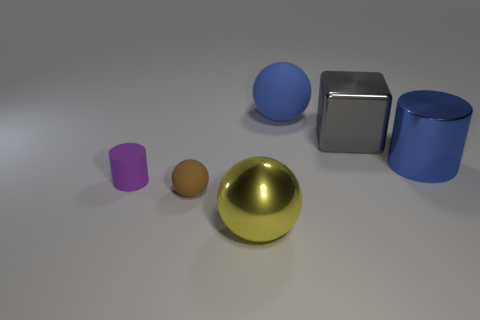Add 1 tiny purple things. How many objects exist? 7 Subtract all cylinders. How many objects are left? 4 Subtract all gray metallic blocks. Subtract all rubber spheres. How many objects are left? 3 Add 1 tiny things. How many tiny things are left? 3 Add 6 blue spheres. How many blue spheres exist? 7 Subtract 0 purple balls. How many objects are left? 6 